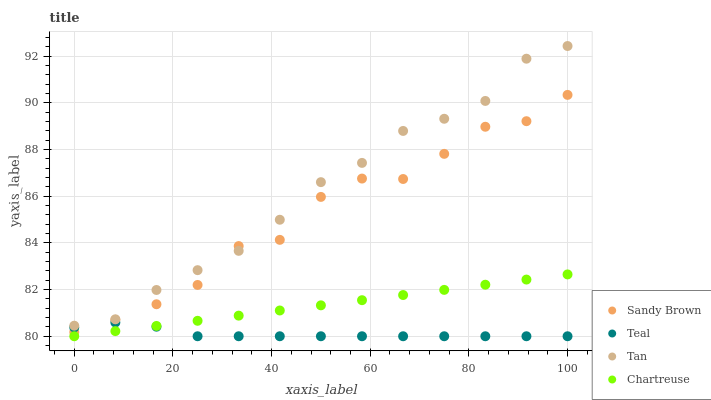Does Teal have the minimum area under the curve?
Answer yes or no. Yes. Does Tan have the maximum area under the curve?
Answer yes or no. Yes. Does Sandy Brown have the minimum area under the curve?
Answer yes or no. No. Does Sandy Brown have the maximum area under the curve?
Answer yes or no. No. Is Chartreuse the smoothest?
Answer yes or no. Yes. Is Sandy Brown the roughest?
Answer yes or no. Yes. Is Sandy Brown the smoothest?
Answer yes or no. No. Is Chartreuse the roughest?
Answer yes or no. No. Does Chartreuse have the lowest value?
Answer yes or no. Yes. Does Sandy Brown have the lowest value?
Answer yes or no. No. Does Tan have the highest value?
Answer yes or no. Yes. Does Sandy Brown have the highest value?
Answer yes or no. No. Is Chartreuse less than Tan?
Answer yes or no. Yes. Is Tan greater than Teal?
Answer yes or no. Yes. Does Tan intersect Sandy Brown?
Answer yes or no. Yes. Is Tan less than Sandy Brown?
Answer yes or no. No. Is Tan greater than Sandy Brown?
Answer yes or no. No. Does Chartreuse intersect Tan?
Answer yes or no. No. 